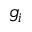Convert formula to latex. <formula><loc_0><loc_0><loc_500><loc_500>g _ { i }</formula> 